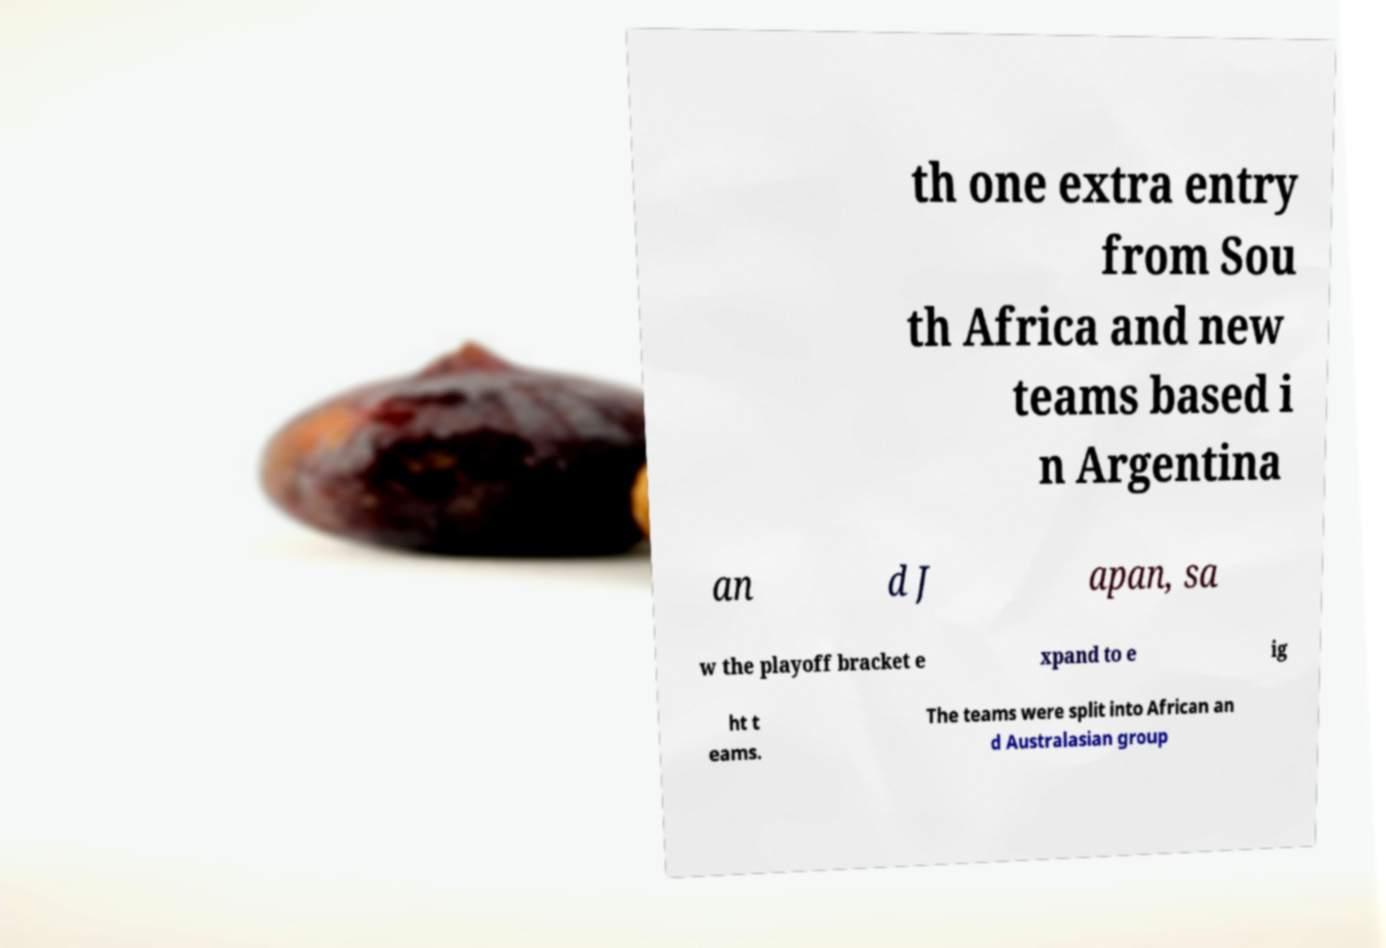I need the written content from this picture converted into text. Can you do that? th one extra entry from Sou th Africa and new teams based i n Argentina an d J apan, sa w the playoff bracket e xpand to e ig ht t eams. The teams were split into African an d Australasian group 